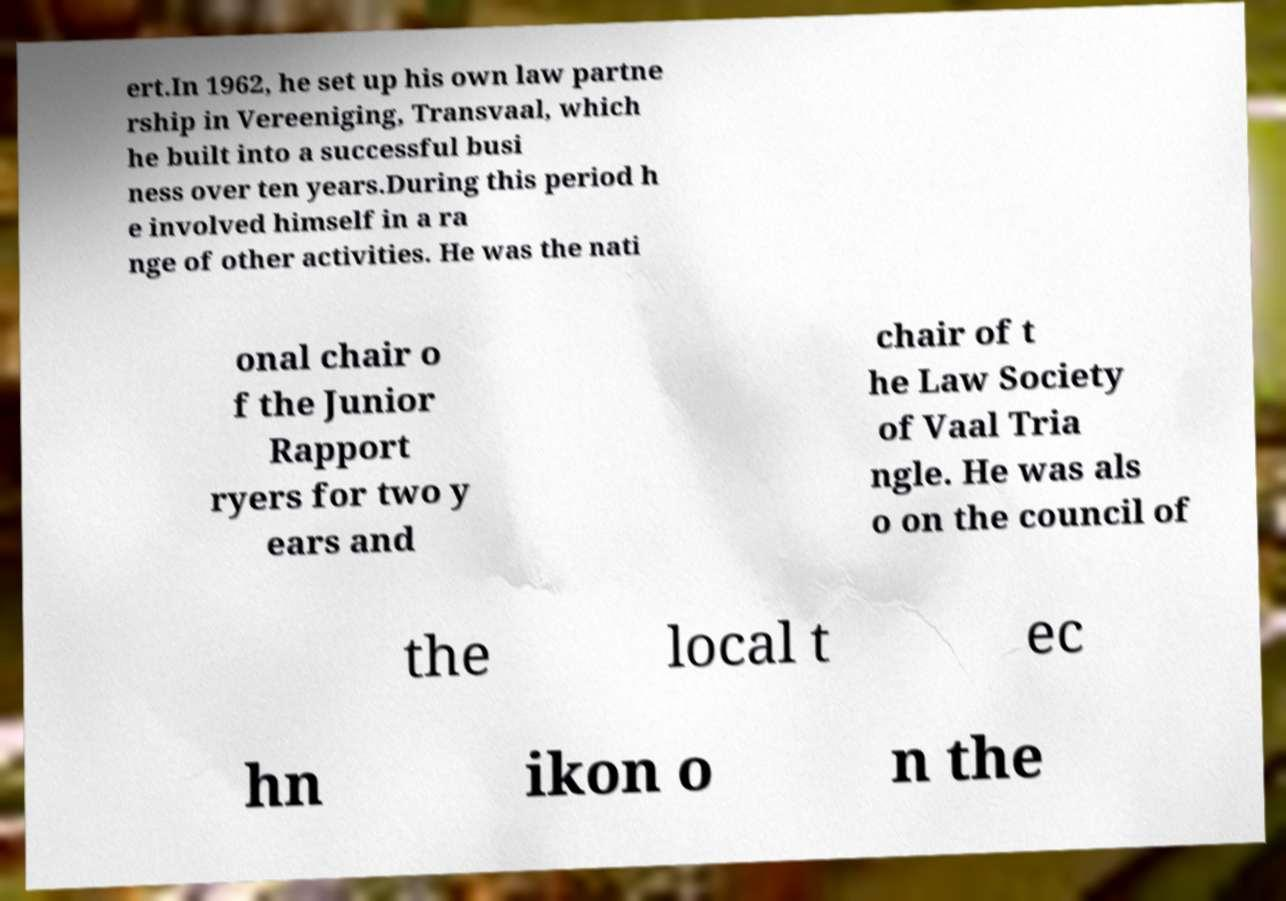Could you extract and type out the text from this image? ert.In 1962, he set up his own law partne rship in Vereeniging, Transvaal, which he built into a successful busi ness over ten years.During this period h e involved himself in a ra nge of other activities. He was the nati onal chair o f the Junior Rapport ryers for two y ears and chair of t he Law Society of Vaal Tria ngle. He was als o on the council of the local t ec hn ikon o n the 